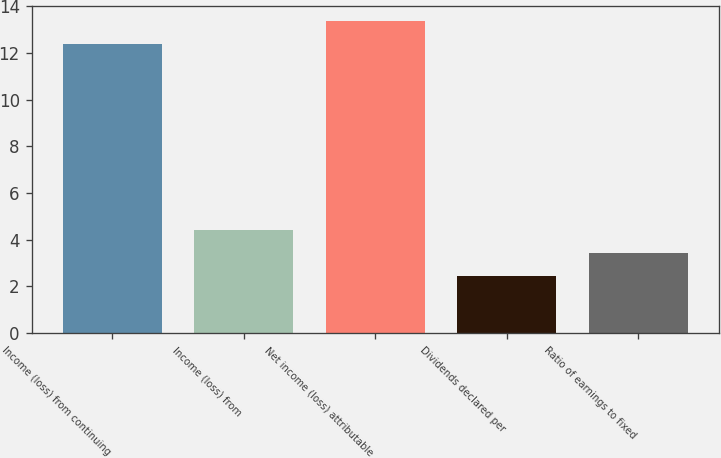Convert chart to OTSL. <chart><loc_0><loc_0><loc_500><loc_500><bar_chart><fcel>Income (loss) from continuing<fcel>Income (loss) from<fcel>Net income (loss) attributable<fcel>Dividends declared per<fcel>Ratio of earnings to fixed<nl><fcel>12.37<fcel>4.42<fcel>13.36<fcel>2.44<fcel>3.43<nl></chart> 